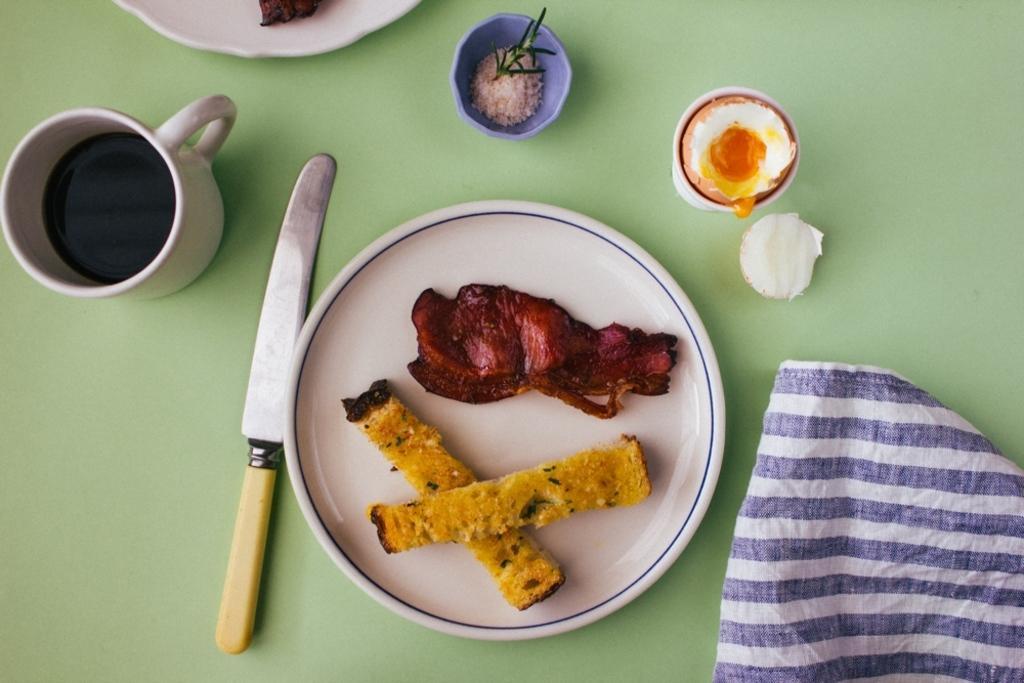Can you describe this image briefly? In the picture I can see few eatables placed in a white plate and there is a knife beside it and there is a cup of coffee in the left corner and there is a cloth in the right corner and there are some other objects in the background. 